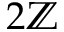Convert formula to latex. <formula><loc_0><loc_0><loc_500><loc_500>2 \mathbb { Z }</formula> 